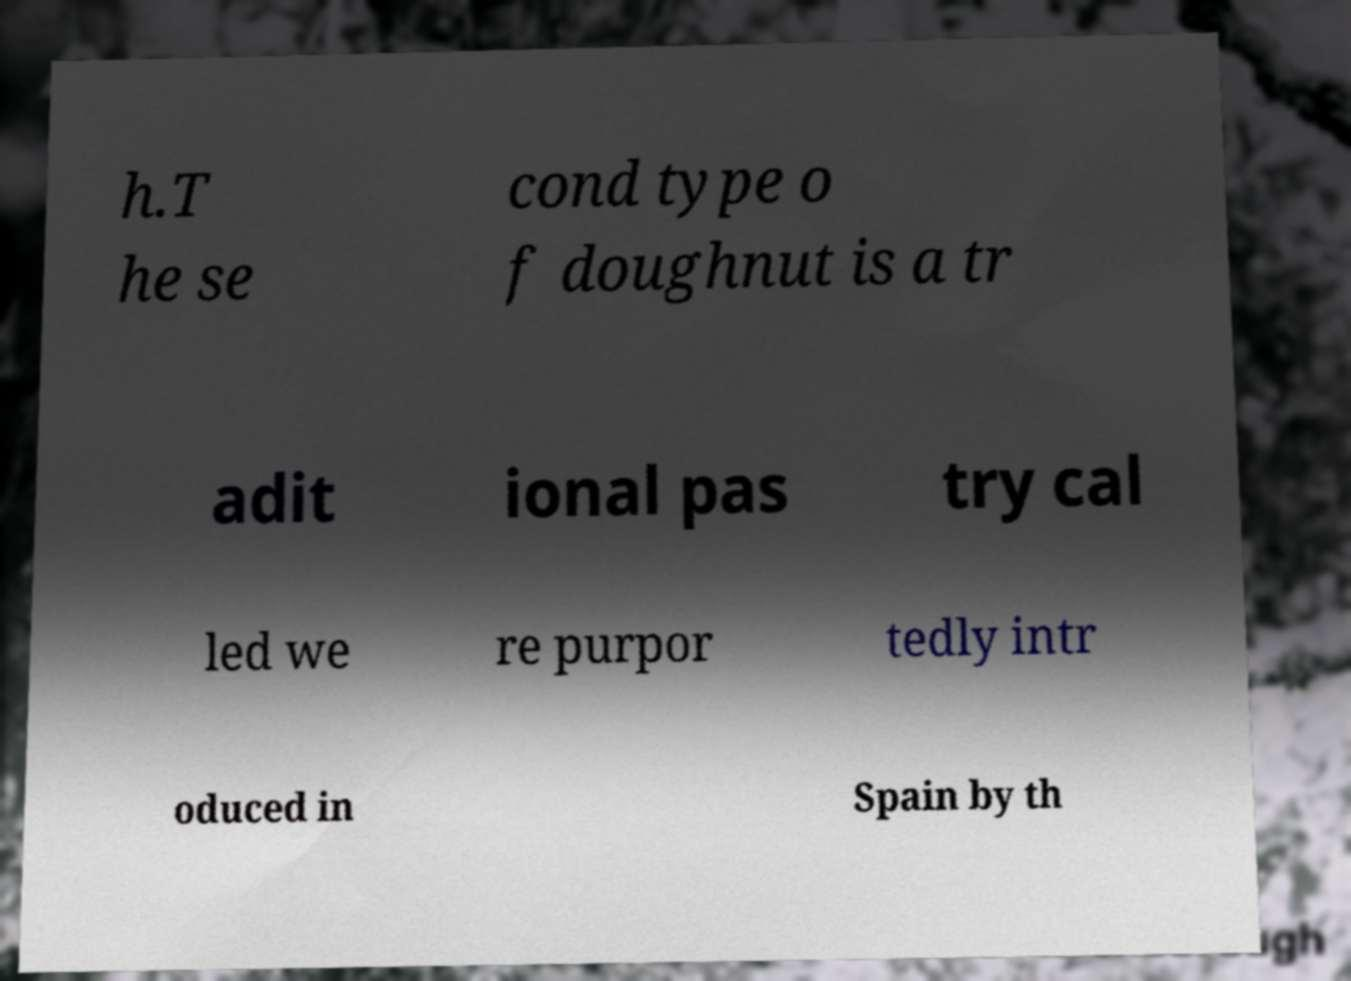I need the written content from this picture converted into text. Can you do that? h.T he se cond type o f doughnut is a tr adit ional pas try cal led we re purpor tedly intr oduced in Spain by th 